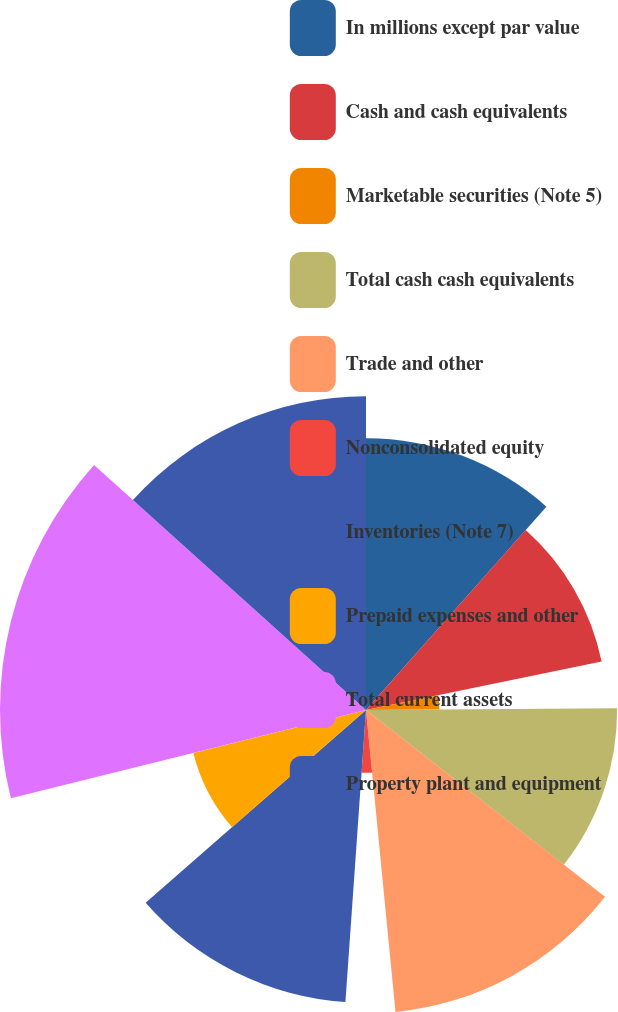Convert chart to OTSL. <chart><loc_0><loc_0><loc_500><loc_500><pie_chart><fcel>In millions except par value<fcel>Cash and cash equivalents<fcel>Marketable securities (Note 5)<fcel>Total cash cash equivalents<fcel>Trade and other<fcel>Nonconsolidated equity<fcel>Inventories (Note 7)<fcel>Prepaid expenses and other<fcel>Total current assets<fcel>Property plant and equipment<nl><fcel>11.55%<fcel>10.22%<fcel>3.12%<fcel>10.67%<fcel>12.89%<fcel>2.67%<fcel>12.44%<fcel>7.56%<fcel>15.55%<fcel>13.33%<nl></chart> 